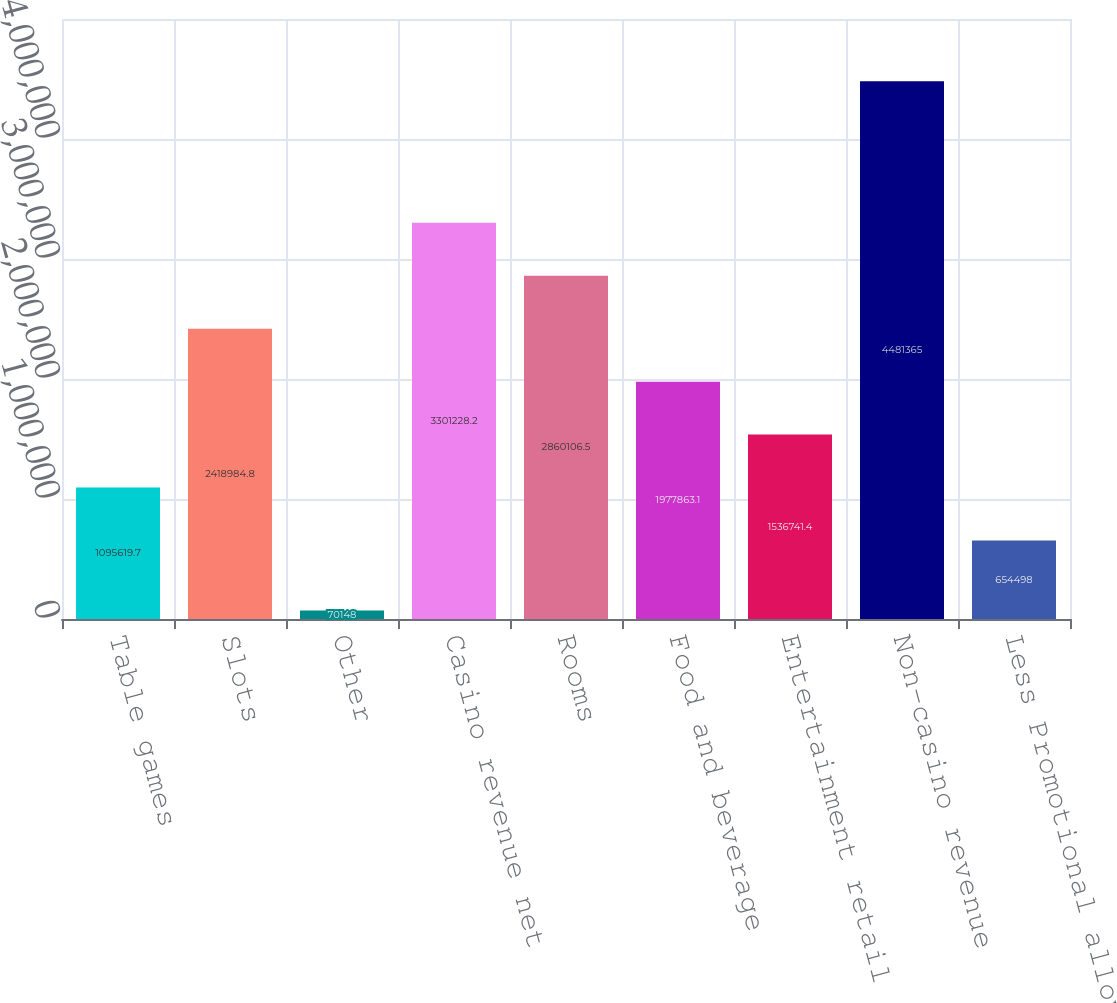Convert chart. <chart><loc_0><loc_0><loc_500><loc_500><bar_chart><fcel>Table games<fcel>Slots<fcel>Other<fcel>Casino revenue net<fcel>Rooms<fcel>Food and beverage<fcel>Entertainment retail and other<fcel>Non-casino revenue<fcel>Less Promotional allowances<nl><fcel>1.09562e+06<fcel>2.41898e+06<fcel>70148<fcel>3.30123e+06<fcel>2.86011e+06<fcel>1.97786e+06<fcel>1.53674e+06<fcel>4.48136e+06<fcel>654498<nl></chart> 